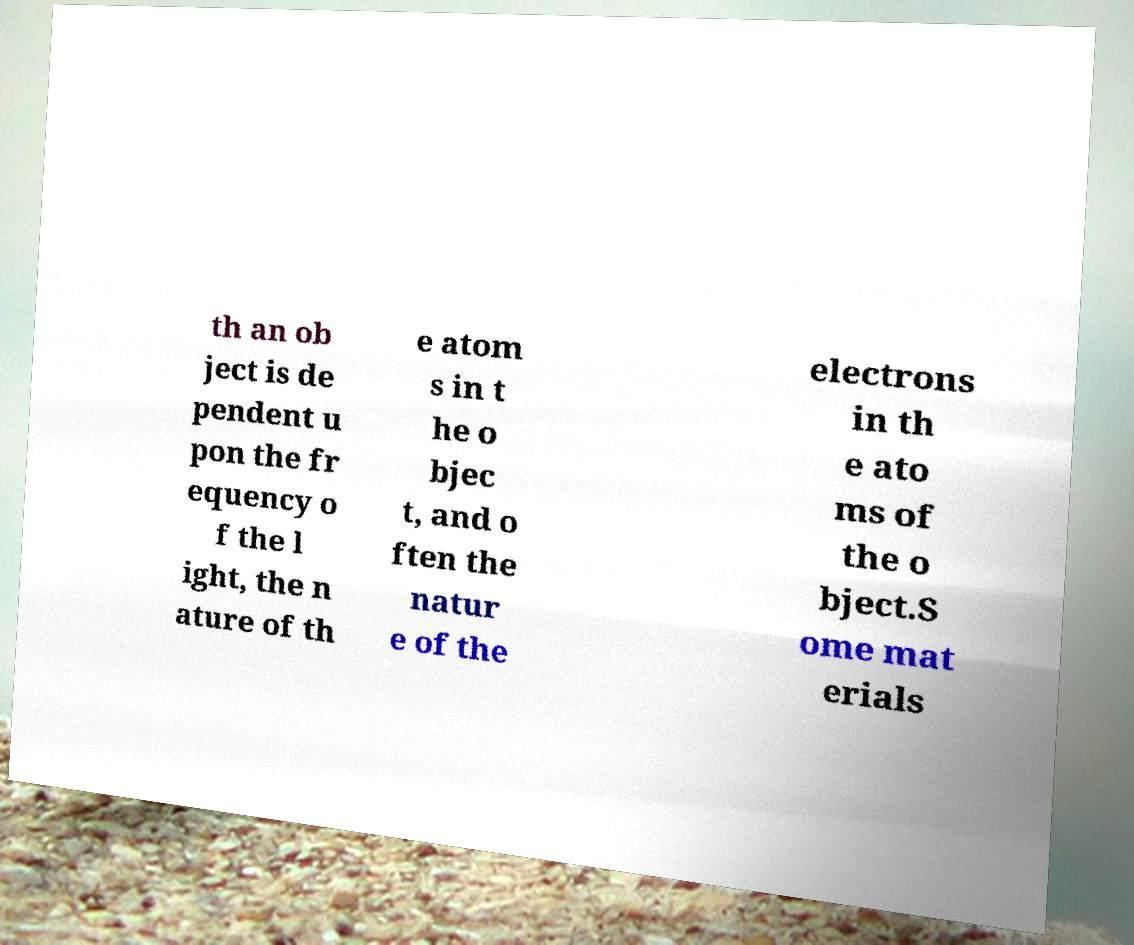Can you accurately transcribe the text from the provided image for me? th an ob ject is de pendent u pon the fr equency o f the l ight, the n ature of th e atom s in t he o bjec t, and o ften the natur e of the electrons in th e ato ms of the o bject.S ome mat erials 